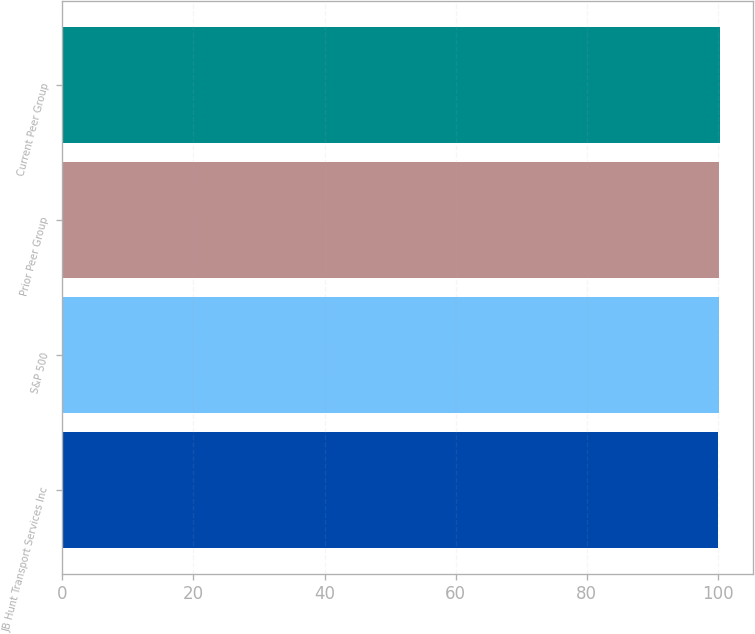<chart> <loc_0><loc_0><loc_500><loc_500><bar_chart><fcel>JB Hunt Transport Services Inc<fcel>S&P 500<fcel>Prior Peer Group<fcel>Current Peer Group<nl><fcel>100<fcel>100.1<fcel>100.2<fcel>100.3<nl></chart> 